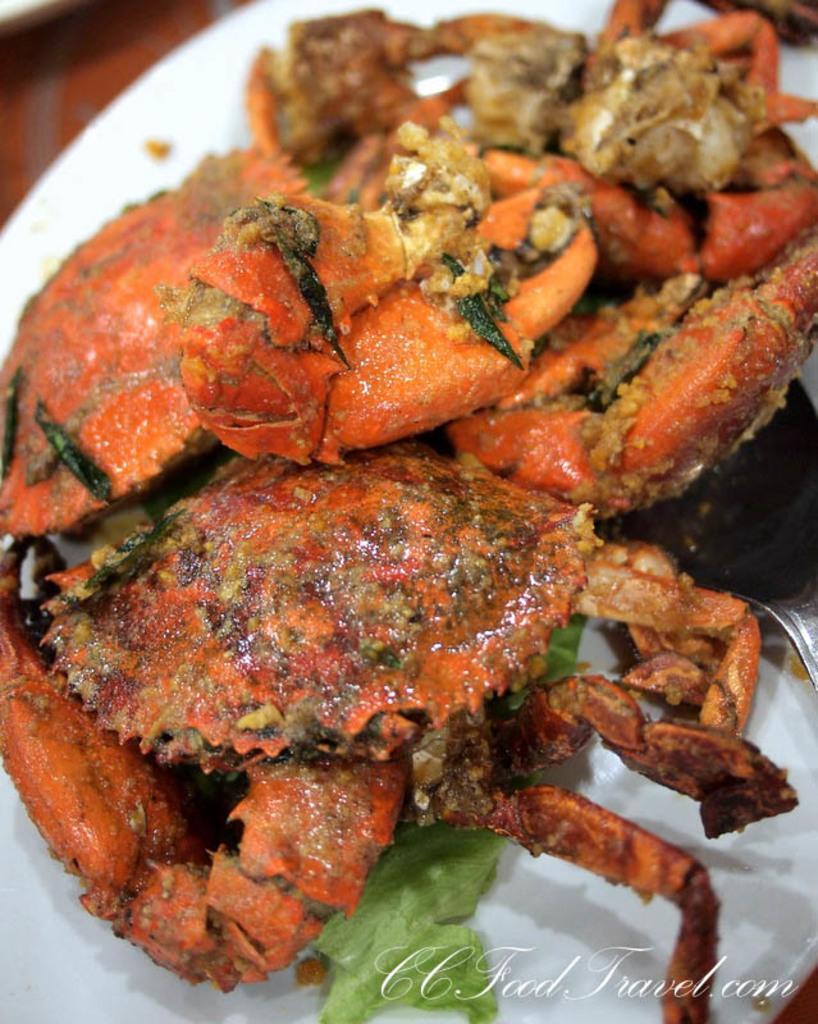Can you describe this image briefly? In the image there is cooked crab served on a white plate. 